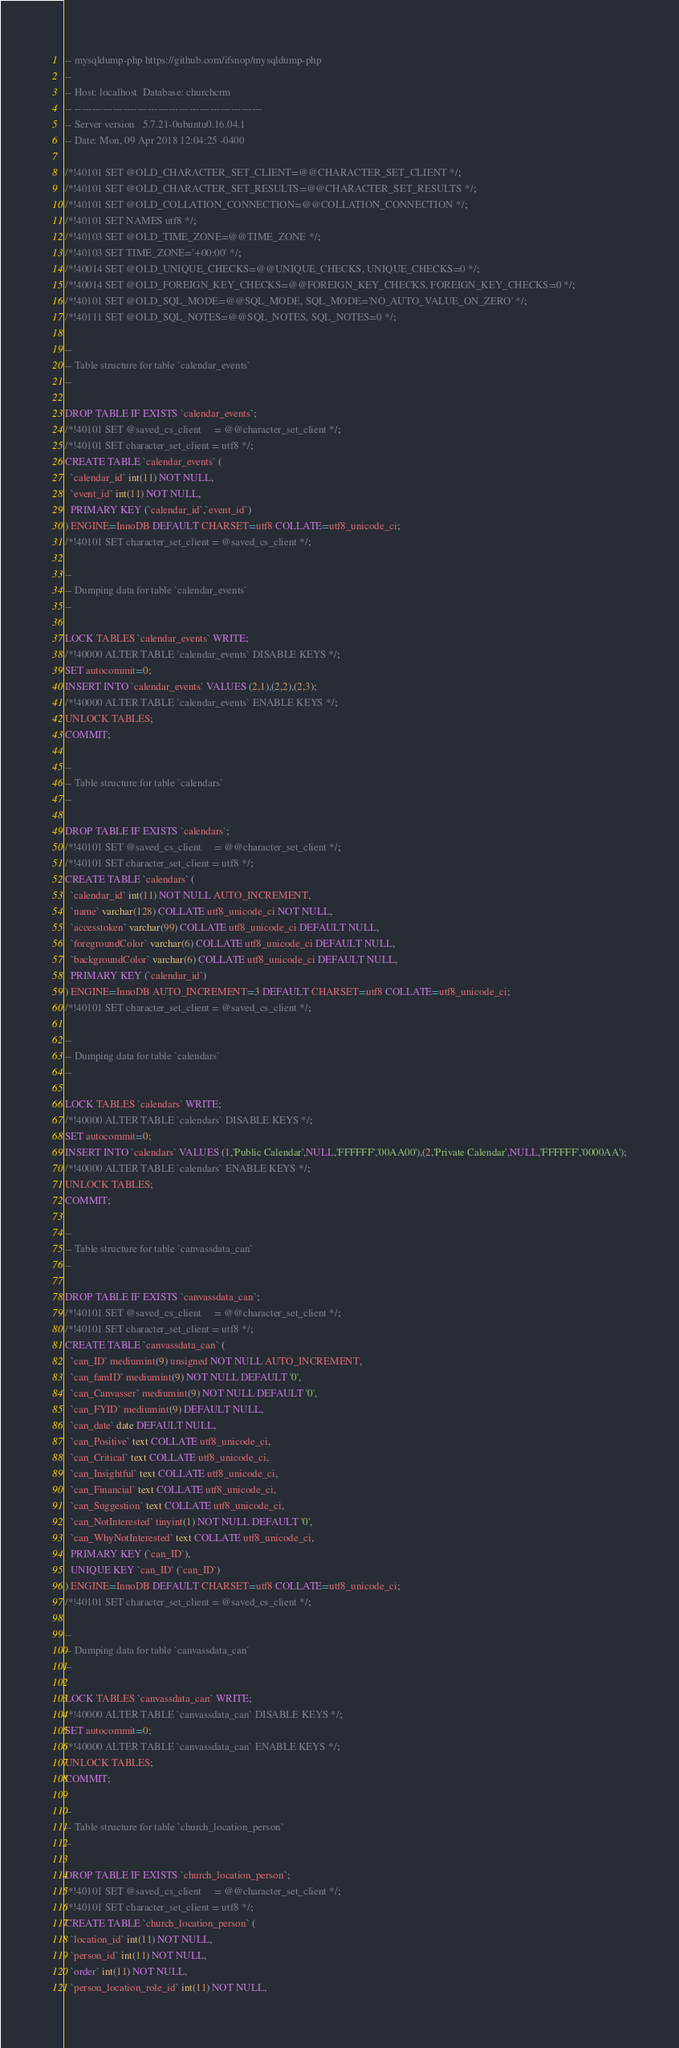Convert code to text. <code><loc_0><loc_0><loc_500><loc_500><_SQL_>-- mysqldump-php https://github.com/ifsnop/mysqldump-php
--
-- Host: localhost	Database: churchcrm
-- ------------------------------------------------------
-- Server version 	5.7.21-0ubuntu0.16.04.1
-- Date: Mon, 09 Apr 2018 12:04:25 -0400

/*!40101 SET @OLD_CHARACTER_SET_CLIENT=@@CHARACTER_SET_CLIENT */;
/*!40101 SET @OLD_CHARACTER_SET_RESULTS=@@CHARACTER_SET_RESULTS */;
/*!40101 SET @OLD_COLLATION_CONNECTION=@@COLLATION_CONNECTION */;
/*!40101 SET NAMES utf8 */;
/*!40103 SET @OLD_TIME_ZONE=@@TIME_ZONE */;
/*!40103 SET TIME_ZONE='+00:00' */;
/*!40014 SET @OLD_UNIQUE_CHECKS=@@UNIQUE_CHECKS, UNIQUE_CHECKS=0 */;
/*!40014 SET @OLD_FOREIGN_KEY_CHECKS=@@FOREIGN_KEY_CHECKS, FOREIGN_KEY_CHECKS=0 */;
/*!40101 SET @OLD_SQL_MODE=@@SQL_MODE, SQL_MODE='NO_AUTO_VALUE_ON_ZERO' */;
/*!40111 SET @OLD_SQL_NOTES=@@SQL_NOTES, SQL_NOTES=0 */;

--
-- Table structure for table `calendar_events`
--

DROP TABLE IF EXISTS `calendar_events`;
/*!40101 SET @saved_cs_client     = @@character_set_client */;
/*!40101 SET character_set_client = utf8 */;
CREATE TABLE `calendar_events` (
  `calendar_id` int(11) NOT NULL,
  `event_id` int(11) NOT NULL,
  PRIMARY KEY (`calendar_id`,`event_id`)
) ENGINE=InnoDB DEFAULT CHARSET=utf8 COLLATE=utf8_unicode_ci;
/*!40101 SET character_set_client = @saved_cs_client */;

--
-- Dumping data for table `calendar_events`
--

LOCK TABLES `calendar_events` WRITE;
/*!40000 ALTER TABLE `calendar_events` DISABLE KEYS */;
SET autocommit=0;
INSERT INTO `calendar_events` VALUES (2,1),(2,2),(2,3);
/*!40000 ALTER TABLE `calendar_events` ENABLE KEYS */;
UNLOCK TABLES;
COMMIT;

--
-- Table structure for table `calendars`
--

DROP TABLE IF EXISTS `calendars`;
/*!40101 SET @saved_cs_client     = @@character_set_client */;
/*!40101 SET character_set_client = utf8 */;
CREATE TABLE `calendars` (
  `calendar_id` int(11) NOT NULL AUTO_INCREMENT,
  `name` varchar(128) COLLATE utf8_unicode_ci NOT NULL,
  `accesstoken` varchar(99) COLLATE utf8_unicode_ci DEFAULT NULL,
  `foregroundColor` varchar(6) COLLATE utf8_unicode_ci DEFAULT NULL,
  `backgroundColor` varchar(6) COLLATE utf8_unicode_ci DEFAULT NULL,
  PRIMARY KEY (`calendar_id`)
) ENGINE=InnoDB AUTO_INCREMENT=3 DEFAULT CHARSET=utf8 COLLATE=utf8_unicode_ci;
/*!40101 SET character_set_client = @saved_cs_client */;

--
-- Dumping data for table `calendars`
--

LOCK TABLES `calendars` WRITE;
/*!40000 ALTER TABLE `calendars` DISABLE KEYS */;
SET autocommit=0;
INSERT INTO `calendars` VALUES (1,'Public Calendar',NULL,'FFFFFF','00AA00'),(2,'Private Calendar',NULL,'FFFFFF','0000AA');
/*!40000 ALTER TABLE `calendars` ENABLE KEYS */;
UNLOCK TABLES;
COMMIT;

--
-- Table structure for table `canvassdata_can`
--

DROP TABLE IF EXISTS `canvassdata_can`;
/*!40101 SET @saved_cs_client     = @@character_set_client */;
/*!40101 SET character_set_client = utf8 */;
CREATE TABLE `canvassdata_can` (
  `can_ID` mediumint(9) unsigned NOT NULL AUTO_INCREMENT,
  `can_famID` mediumint(9) NOT NULL DEFAULT '0',
  `can_Canvasser` mediumint(9) NOT NULL DEFAULT '0',
  `can_FYID` mediumint(9) DEFAULT NULL,
  `can_date` date DEFAULT NULL,
  `can_Positive` text COLLATE utf8_unicode_ci,
  `can_Critical` text COLLATE utf8_unicode_ci,
  `can_Insightful` text COLLATE utf8_unicode_ci,
  `can_Financial` text COLLATE utf8_unicode_ci,
  `can_Suggestion` text COLLATE utf8_unicode_ci,
  `can_NotInterested` tinyint(1) NOT NULL DEFAULT '0',
  `can_WhyNotInterested` text COLLATE utf8_unicode_ci,
  PRIMARY KEY (`can_ID`),
  UNIQUE KEY `can_ID` (`can_ID`)
) ENGINE=InnoDB DEFAULT CHARSET=utf8 COLLATE=utf8_unicode_ci;
/*!40101 SET character_set_client = @saved_cs_client */;

--
-- Dumping data for table `canvassdata_can`
--

LOCK TABLES `canvassdata_can` WRITE;
/*!40000 ALTER TABLE `canvassdata_can` DISABLE KEYS */;
SET autocommit=0;
/*!40000 ALTER TABLE `canvassdata_can` ENABLE KEYS */;
UNLOCK TABLES;
COMMIT;

--
-- Table structure for table `church_location_person`
--

DROP TABLE IF EXISTS `church_location_person`;
/*!40101 SET @saved_cs_client     = @@character_set_client */;
/*!40101 SET character_set_client = utf8 */;
CREATE TABLE `church_location_person` (
  `location_id` int(11) NOT NULL,
  `person_id` int(11) NOT NULL,
  `order` int(11) NOT NULL,
  `person_location_role_id` int(11) NOT NULL,</code> 